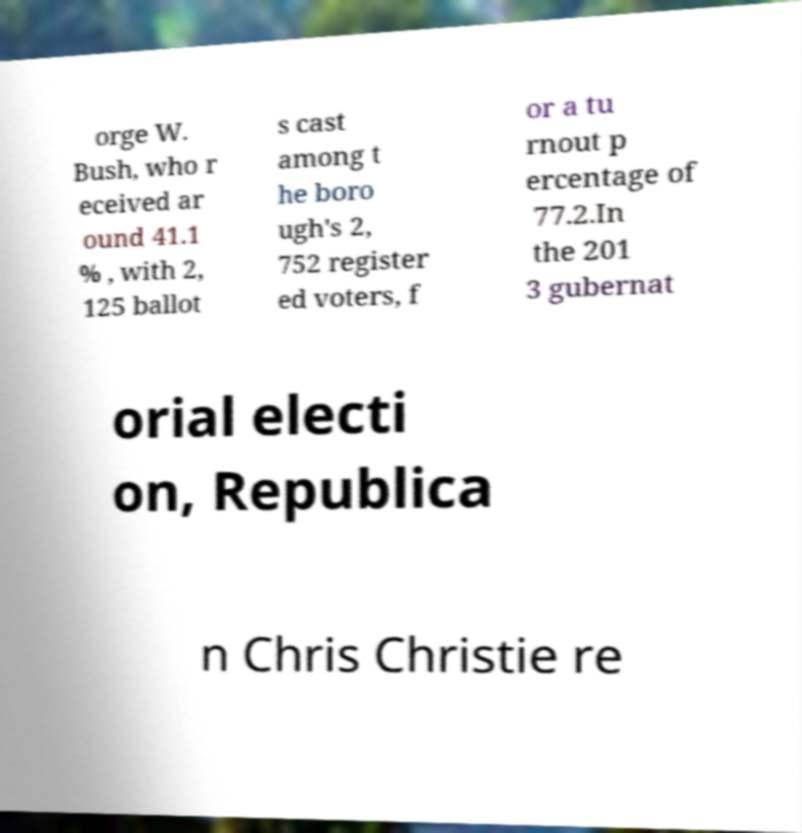Please read and relay the text visible in this image. What does it say? orge W. Bush, who r eceived ar ound 41.1 % , with 2, 125 ballot s cast among t he boro ugh's 2, 752 register ed voters, f or a tu rnout p ercentage of 77.2.In the 201 3 gubernat orial electi on, Republica n Chris Christie re 